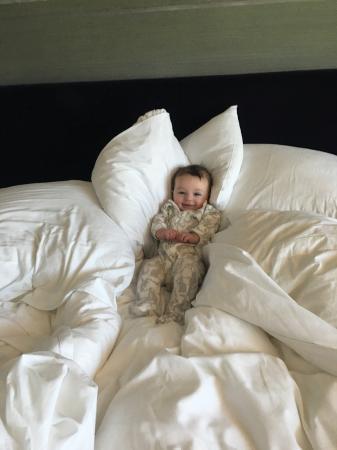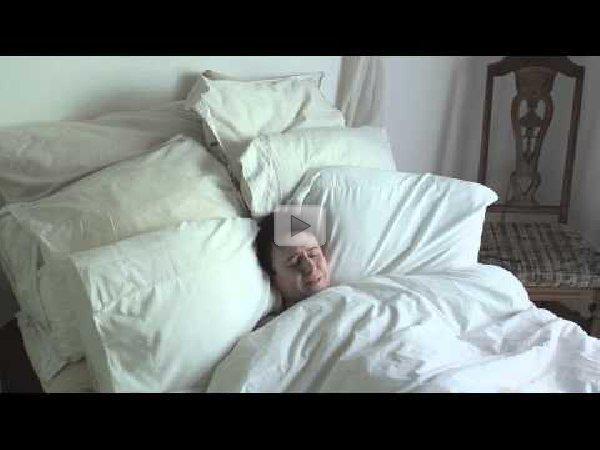The first image is the image on the left, the second image is the image on the right. For the images shown, is this caption "There is at least one human lying on a bed." true? Answer yes or no. Yes. 